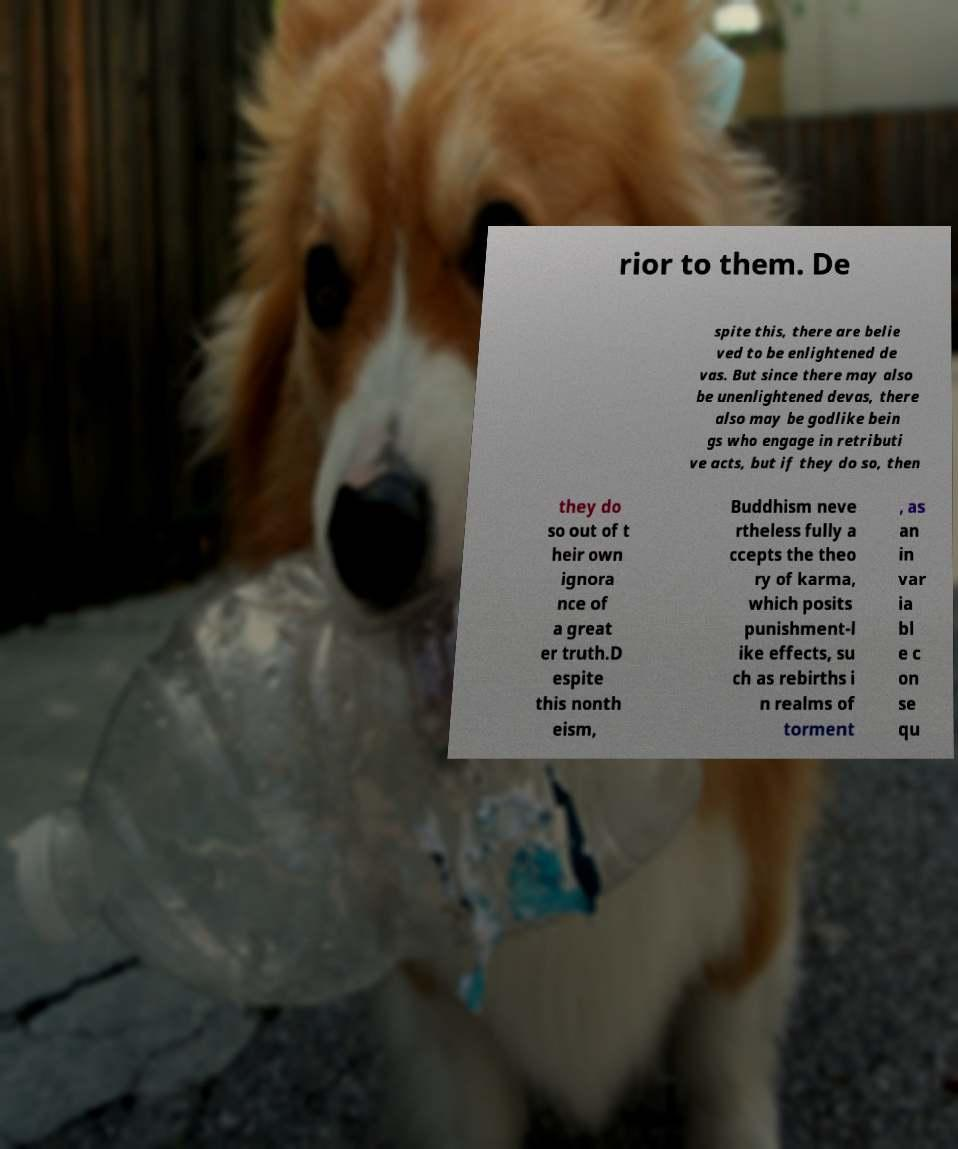Can you accurately transcribe the text from the provided image for me? rior to them. De spite this, there are belie ved to be enlightened de vas. But since there may also be unenlightened devas, there also may be godlike bein gs who engage in retributi ve acts, but if they do so, then they do so out of t heir own ignora nce of a great er truth.D espite this nonth eism, Buddhism neve rtheless fully a ccepts the theo ry of karma, which posits punishment-l ike effects, su ch as rebirths i n realms of torment , as an in var ia bl e c on se qu 